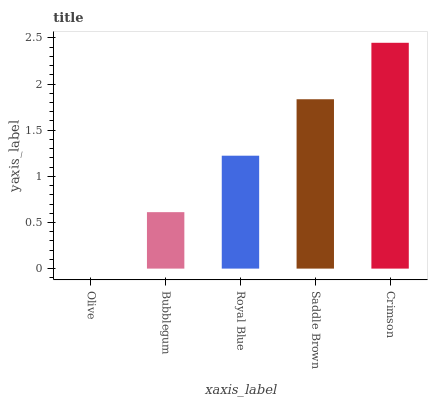Is Olive the minimum?
Answer yes or no. Yes. Is Crimson the maximum?
Answer yes or no. Yes. Is Bubblegum the minimum?
Answer yes or no. No. Is Bubblegum the maximum?
Answer yes or no. No. Is Bubblegum greater than Olive?
Answer yes or no. Yes. Is Olive less than Bubblegum?
Answer yes or no. Yes. Is Olive greater than Bubblegum?
Answer yes or no. No. Is Bubblegum less than Olive?
Answer yes or no. No. Is Royal Blue the high median?
Answer yes or no. Yes. Is Royal Blue the low median?
Answer yes or no. Yes. Is Crimson the high median?
Answer yes or no. No. Is Bubblegum the low median?
Answer yes or no. No. 